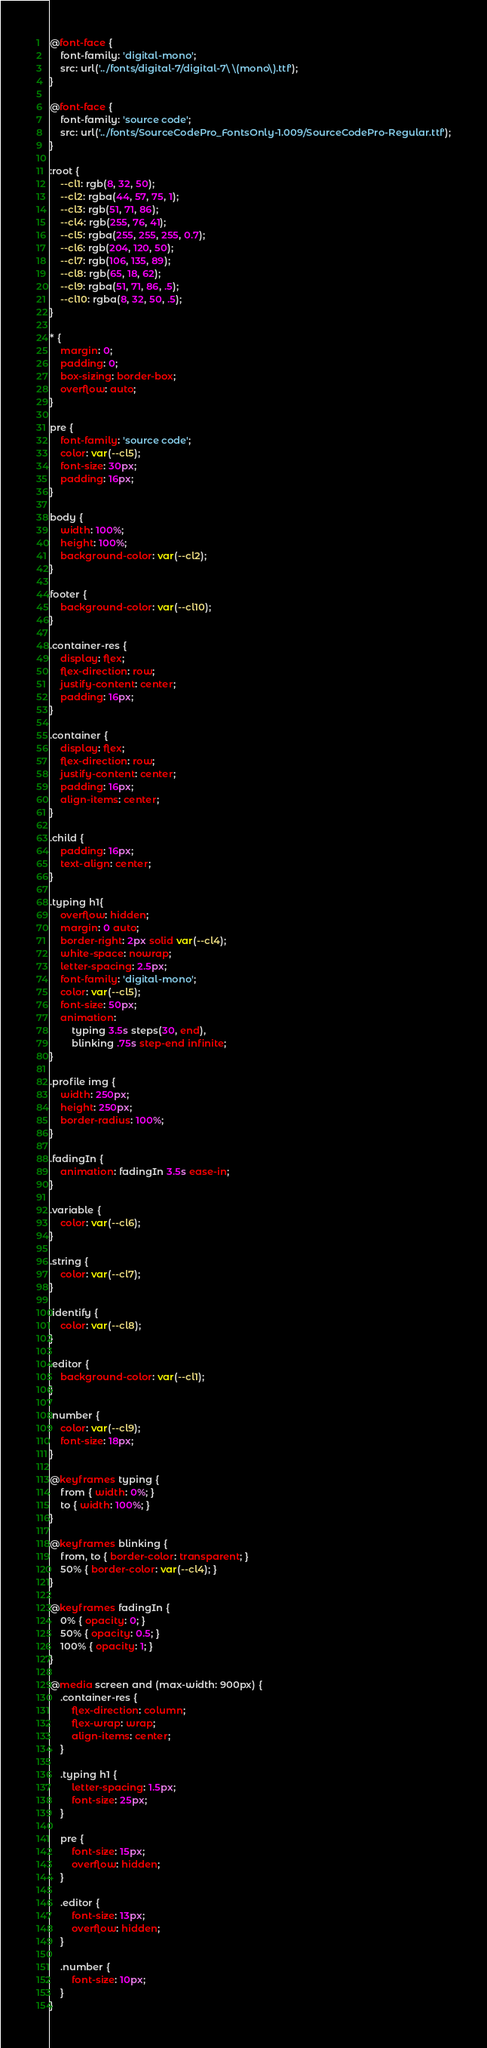Convert code to text. <code><loc_0><loc_0><loc_500><loc_500><_CSS_>@font-face {
    font-family: 'digital-mono';
    src: url('../fonts/digital-7/digital-7\ \(mono\).ttf');
}

@font-face {
    font-family: 'source code';
    src: url('../fonts/SourceCodePro_FontsOnly-1.009/SourceCodePro-Regular.ttf');
}

:root {
    --cl1: rgb(8, 32, 50);
    --cl2: rgba(44, 57, 75, 1);
    --cl3: rgb(51, 71, 86);
    --cl4: rgb(255, 76, 41);
    --cl5: rgba(255, 255, 255, 0.7);
    --cl6: rgb(204, 120, 50);
    --cl7: rgb(106, 135, 89);
    --cl8: rgb(65, 18, 62);
    --cl9: rgba(51, 71, 86, .5);
    --cl10: rgba(8, 32, 50, .5);
}

* {
    margin: 0;
    padding: 0;
    box-sizing: border-box;
    overflow: auto;
}

pre {
    font-family: 'source code';
    color: var(--cl5);
    font-size: 30px;
    padding: 16px;
}

body {
    width: 100%;
    height: 100%;
    background-color: var(--cl2);
}

footer {
    background-color: var(--cl10);
}

.container-res {
    display: flex;
    flex-direction: row;
    justify-content: center;
    padding: 16px;
}

.container {
    display: flex;
    flex-direction: row;
    justify-content: center;
    padding: 16px;
    align-items: center;
}

.child {
    padding: 16px;
    text-align: center;
}

.typing h1{
    overflow: hidden;
    margin: 0 auto;
    border-right: 2px solid var(--cl4);
    white-space: nowrap;
    letter-spacing: 2.5px;
    font-family: 'digital-mono';
    color: var(--cl5);
    font-size: 50px;
    animation: 
        typing 3.5s steps(30, end),
        blinking .75s step-end infinite;
}

.profile img {
    width: 250px;
    height: 250px;
    border-radius: 100%;
}

.fadingIn {
    animation: fadingIn 3.5s ease-in;
}

.variable {
    color: var(--cl6);
}

.string {
    color: var(--cl7);
}

.identify {
    color: var(--cl8);
}

.editor {
    background-color: var(--cl1);
}

.number {
    color: var(--cl9);
    font-size: 18px;
}

@keyframes typing {
    from { width: 0%; }
    to { width: 100%; }
}

@keyframes blinking {
    from, to { border-color: transparent; }
    50% { border-color: var(--cl4); }
}

@keyframes fadingIn {
    0% { opacity: 0; }
    50% { opacity: 0.5; }
    100% { opacity: 1; }
}

@media screen and (max-width: 900px) {
    .container-res {
        flex-direction: column;
        flex-wrap: wrap;
        align-items: center;
    }

    .typing h1 {
        letter-spacing: 1.5px;
        font-size: 25px;
    }

    pre {
        font-size: 15px;
        overflow: hidden;
    }

    .editor {
        font-size: 13px;
        overflow: hidden;
    }

    .number {
        font-size: 10px;
    }
}</code> 